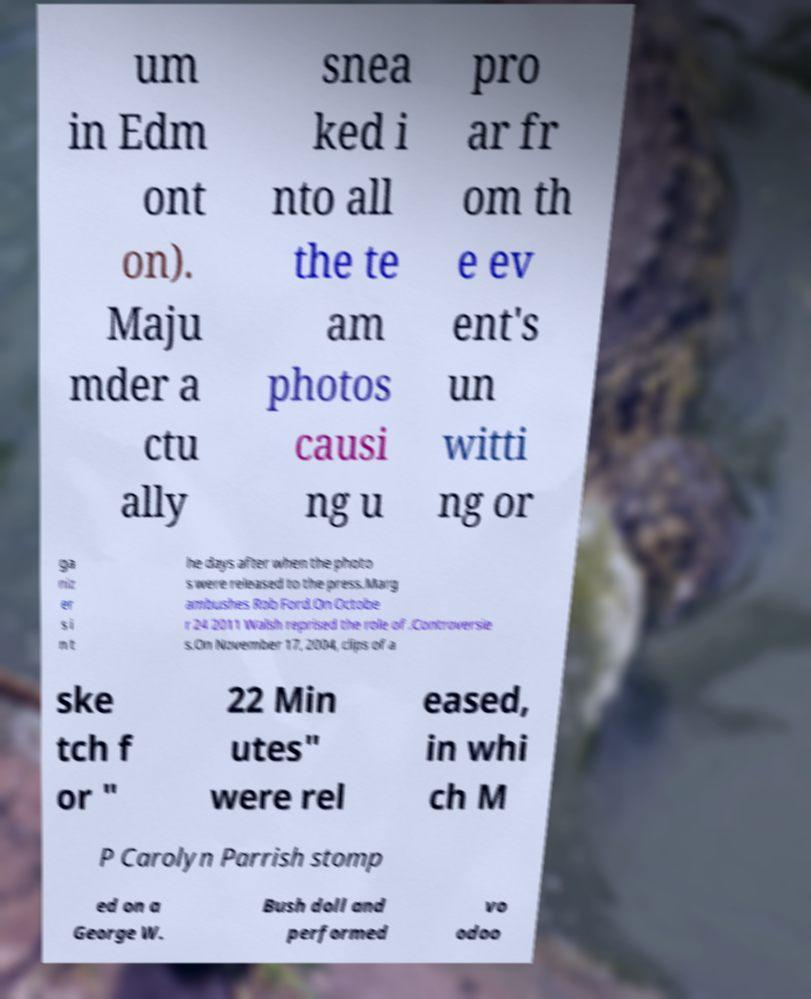There's text embedded in this image that I need extracted. Can you transcribe it verbatim? um in Edm ont on). Maju mder a ctu ally snea ked i nto all the te am photos causi ng u pro ar fr om th e ev ent's un witti ng or ga niz er s i n t he days after when the photo s were released to the press.Marg ambushes Rob Ford.On Octobe r 24 2011 Walsh reprised the role of .Controversie s.On November 17, 2004, clips of a ske tch f or " 22 Min utes" were rel eased, in whi ch M P Carolyn Parrish stomp ed on a George W. Bush doll and performed vo odoo 